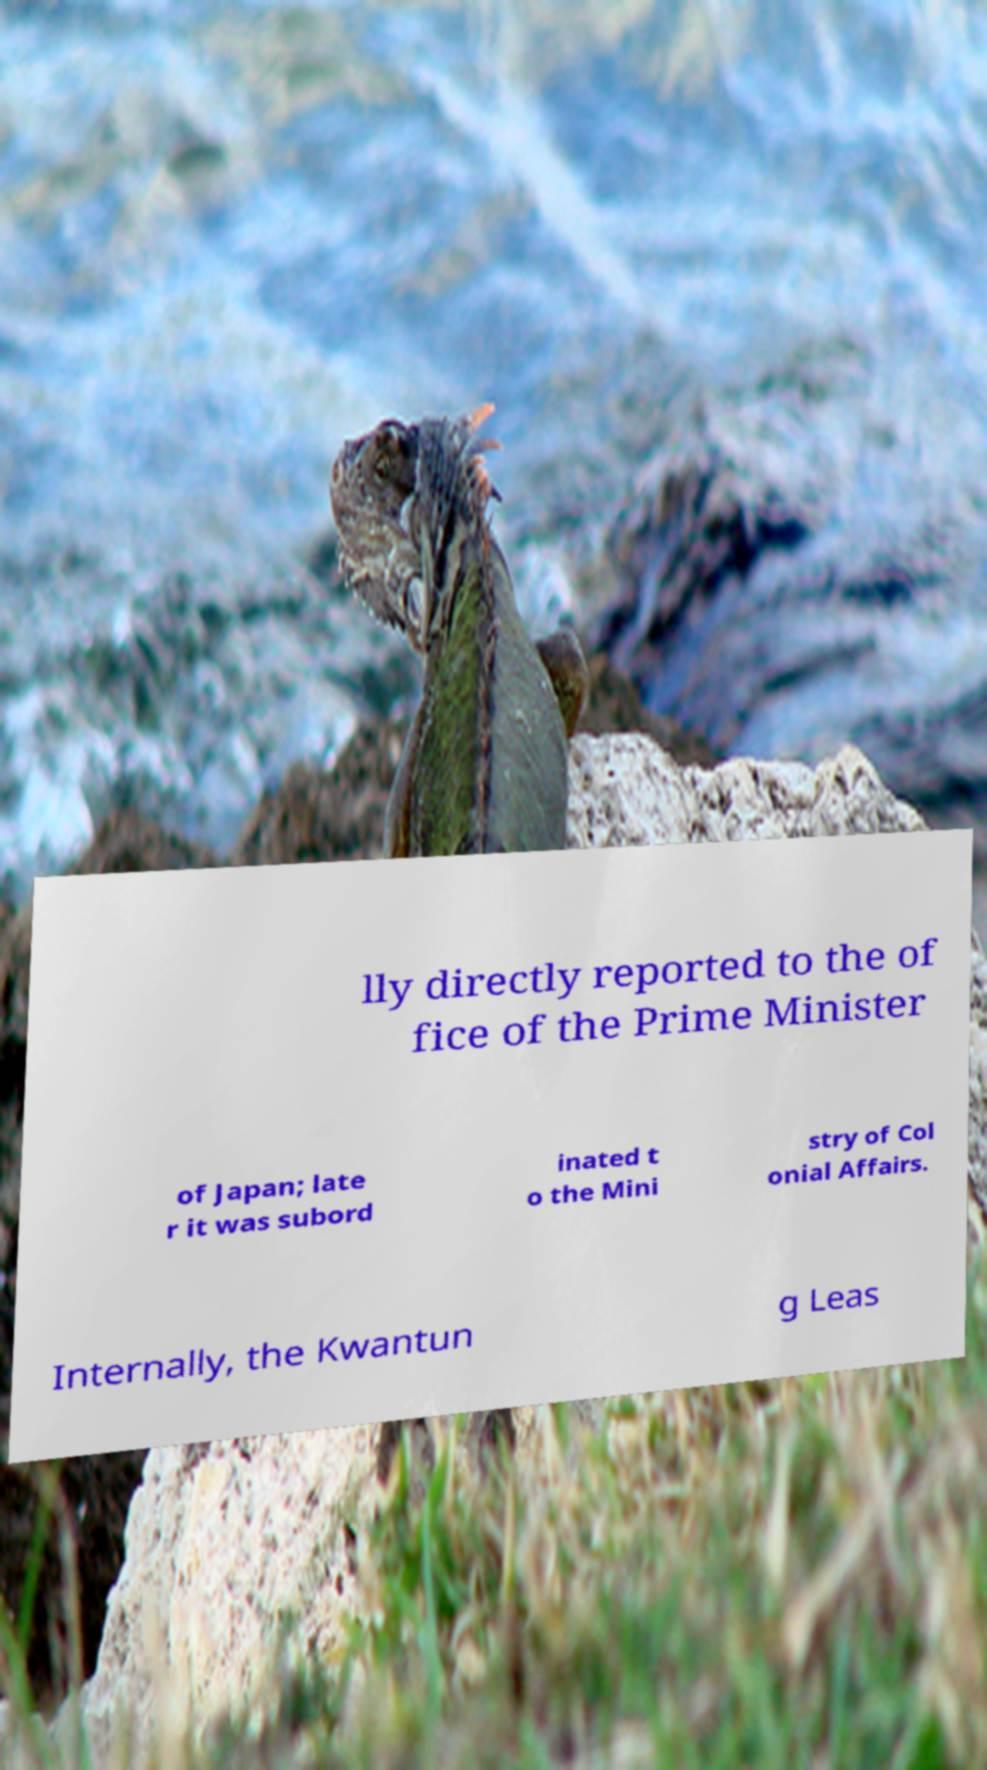Could you assist in decoding the text presented in this image and type it out clearly? lly directly reported to the of fice of the Prime Minister of Japan; late r it was subord inated t o the Mini stry of Col onial Affairs. Internally, the Kwantun g Leas 